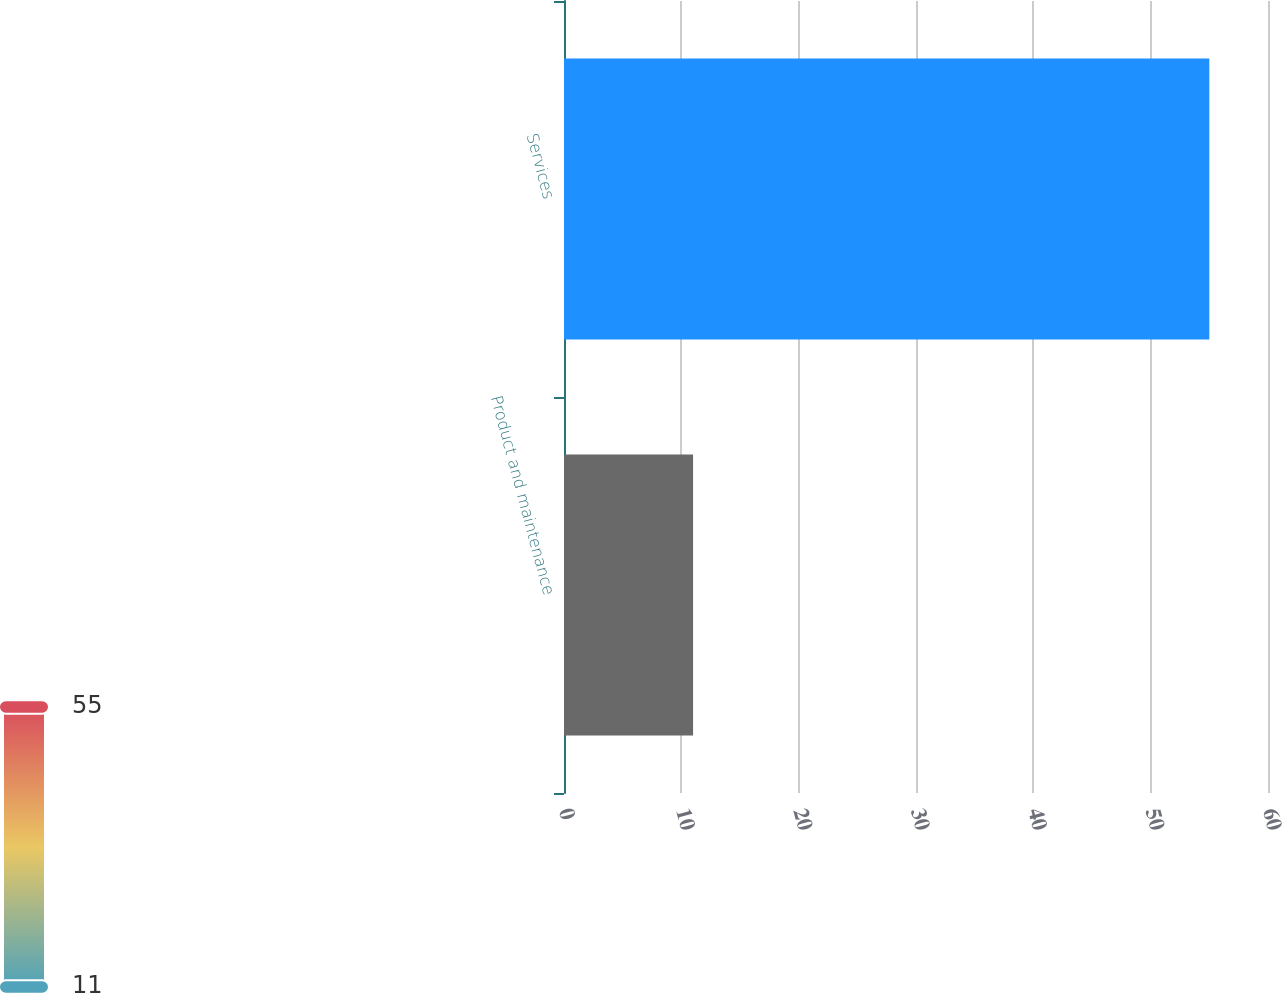<chart> <loc_0><loc_0><loc_500><loc_500><bar_chart><fcel>Product and maintenance<fcel>Services<nl><fcel>11<fcel>55<nl></chart> 